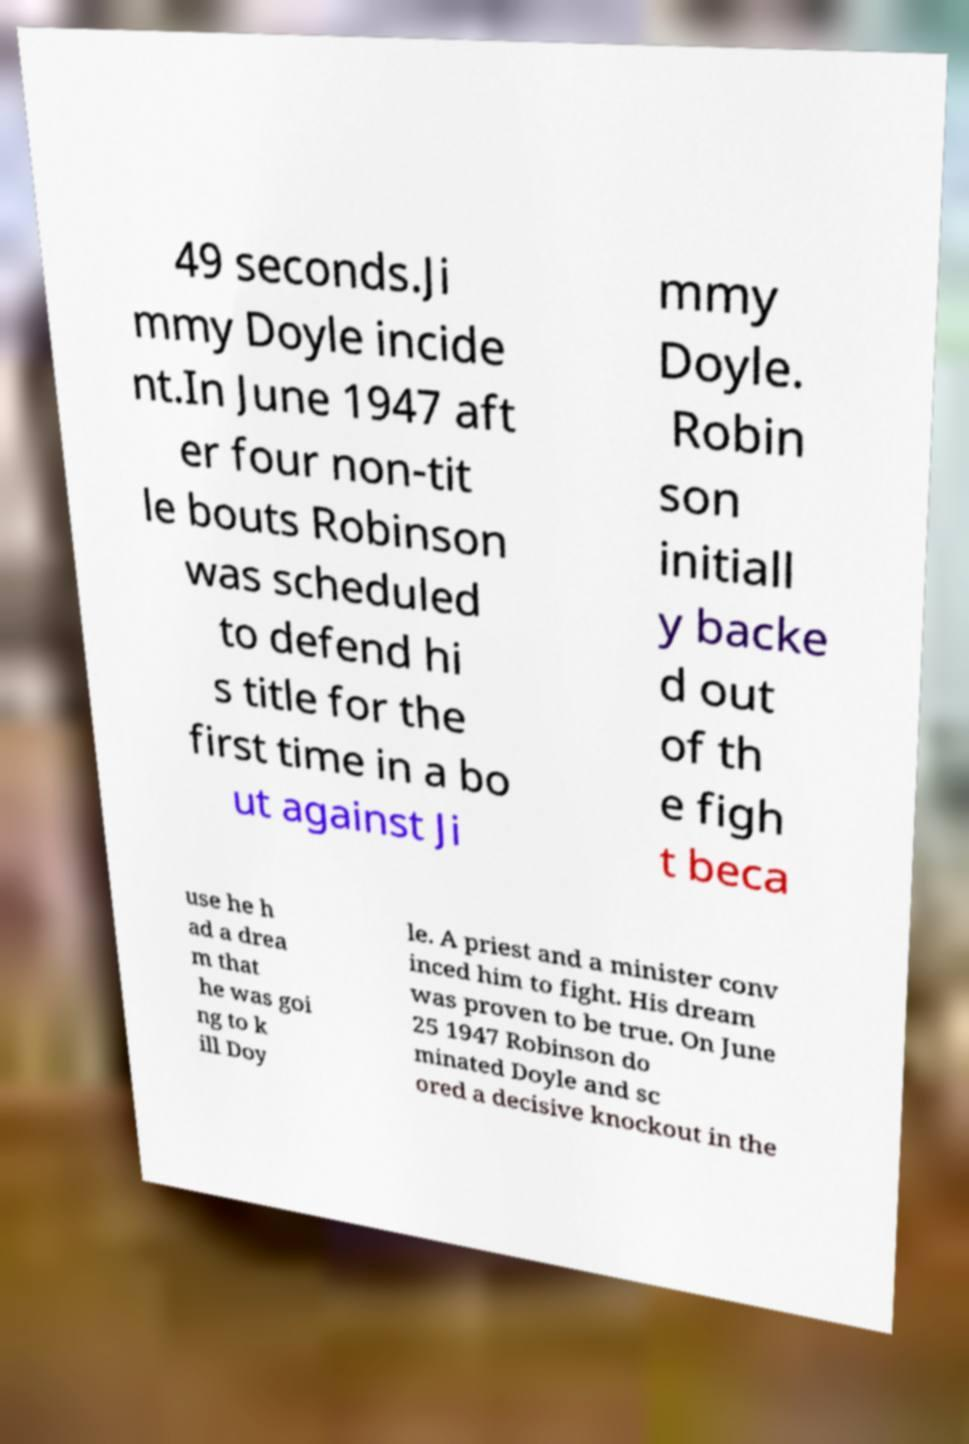There's text embedded in this image that I need extracted. Can you transcribe it verbatim? 49 seconds.Ji mmy Doyle incide nt.In June 1947 aft er four non-tit le bouts Robinson was scheduled to defend hi s title for the first time in a bo ut against Ji mmy Doyle. Robin son initiall y backe d out of th e figh t beca use he h ad a drea m that he was goi ng to k ill Doy le. A priest and a minister conv inced him to fight. His dream was proven to be true. On June 25 1947 Robinson do minated Doyle and sc ored a decisive knockout in the 